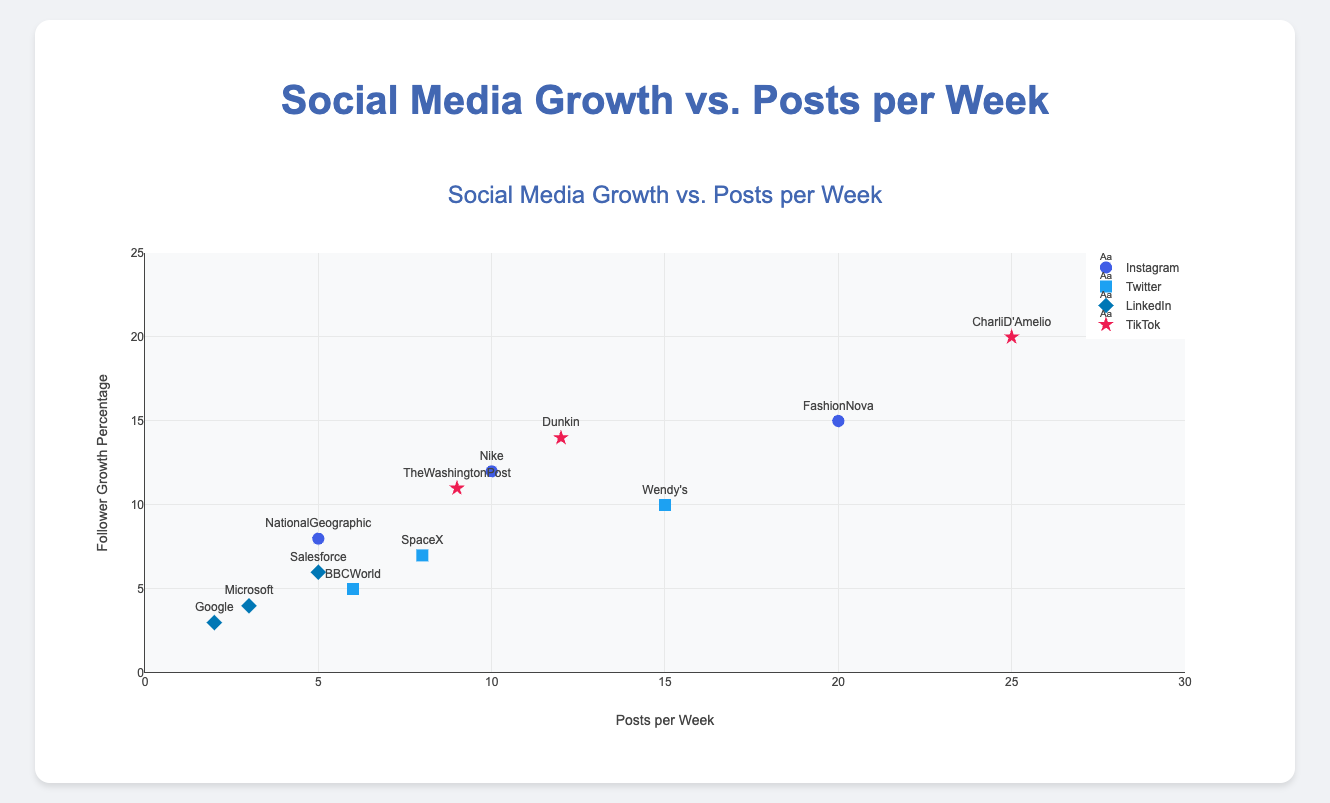What is the title of the figure? The title of the figure is often placed at the top center and it provides an overview of what the chart is about. In this case, it reads "Social Media Growth vs. Posts per Week."
Answer: Social Media Growth vs. Posts per Week Which platform has the highest follower growth percentage? To find the platform with the highest follower growth percentage, look at the y-axis values across each platform. The highest y-axis value belongs to TikTok with "CharliD'Amelio" having a 20% follower growth.
Answer: TikTok What is the range of posts per week shown on the x-axis? The range of the x-axis can be identified by looking at the minimum and maximum values. The x-axis ranges from 0 to 30 posts per week as indicated by the tick marks.
Answer: 0 to 30 Which Twitter account has the most posts per week and how many are they? To identify the Twitter account with the most posts per week, look at the data points labeled with Twitter. Wendy's has the highest number of posts per week among Twitter accounts with 15 posts.
Answer: Wendy's, 15 posts What is the average follower growth percentage for LinkedIn accounts? Look at the y-values for LinkedIn accounts: Microsoft (4%), Google (3%), Salesforce (6%). Their sum is 4 + 3 + 6 = 13, and there are 3 accounts. Average is 13/3.
Answer: 4.33% Is there a positive correlation between posts per week and follower growth percentage for Instagram accounts? To determine the correlation, observe if higher posts per week tend to align with higher follower growth percentages for Instagram accounts. For Instagram, FashionNova (20 posts, 15%), Nike (10 posts, 12%), NationalGeographic (5 posts, 8%) show a positive trend.
Answer: Yes Which platform has the widest range of posts per week? Calculate the range for each platform by subtracting the minimum posts per week from the maximum. TikTok has the widest range: CharliD'Amelio (25) minus TheWashingtonPost (9) = 16.
Answer: TikTok Between TikTok's "Dunkin" and Instagram's "Nike", which account has a higher follower growth percentage and by how much? Compare the y-values for Dunkin (14%) and Nike (12%). Dunkin's follower growth percentage is higher by 2%.
Answer: Dunkin, 2% For accounts that post 5 times per week, which ones have the same follower growth percentage? Find data points where posts per week are 5. NationalGeographic (Instagram) and Salesforce (LinkedIn) both post 5 times per week with growth percentages of 8% and 6%, respectively.
Answer: None have the same percentage Which social media platform has the highest concentration of data points on the scatter plot, and how many accounts are there? By counting the number of data points in each platform, Instagram, Twitter, LinkedIn, and TikTok platforms have 3 points each. Hence, all have equal concentration.
Answer: Instagram, Twitter, LinkedIn, and TikTok each have 3 accounts 